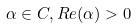<formula> <loc_0><loc_0><loc_500><loc_500>\alpha \in C , R e ( \alpha ) > 0</formula> 